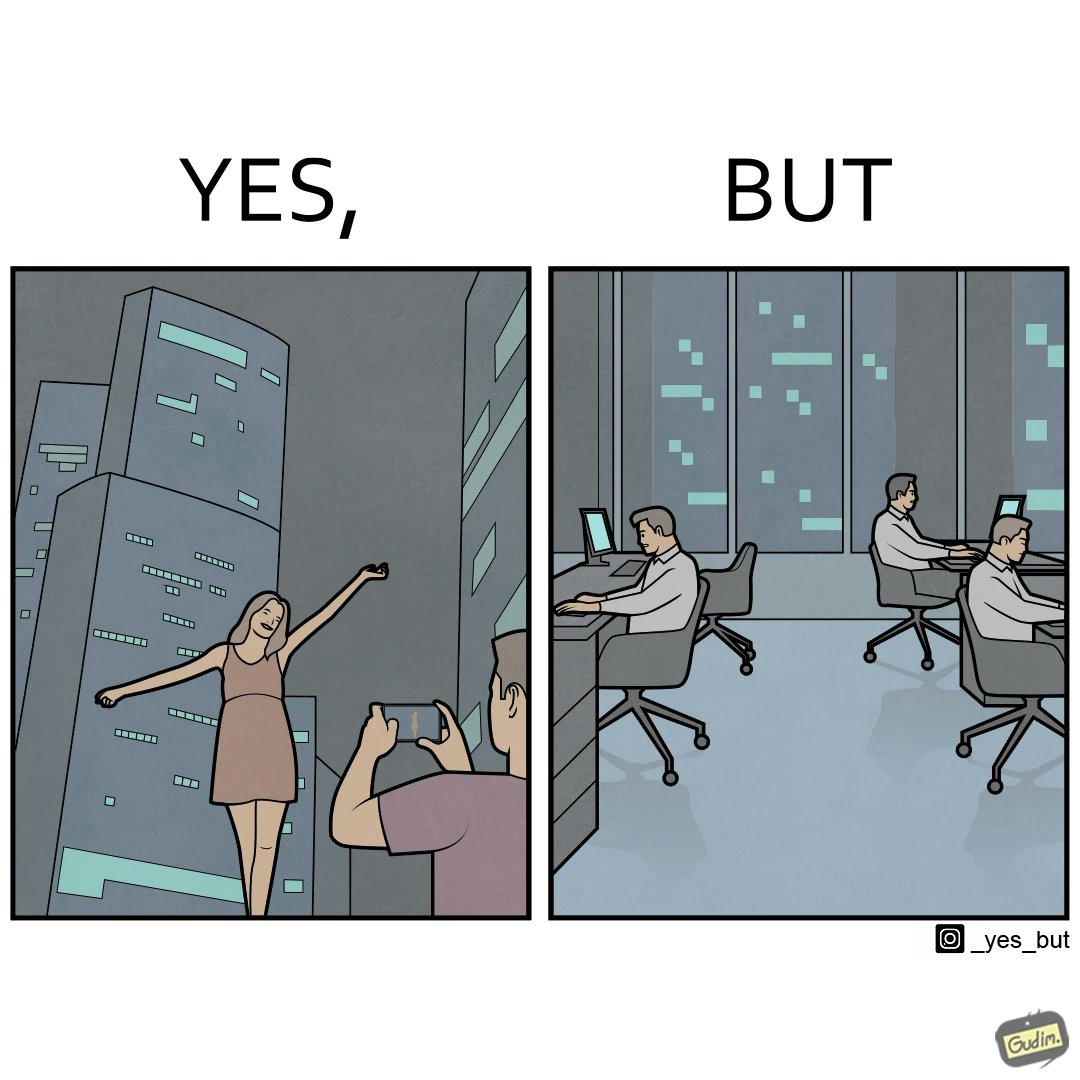What does this image depict? The images are ironic since it shows how a holiday destination for a woman and a man is actually a workplace for many others where they are toiling away everyday 